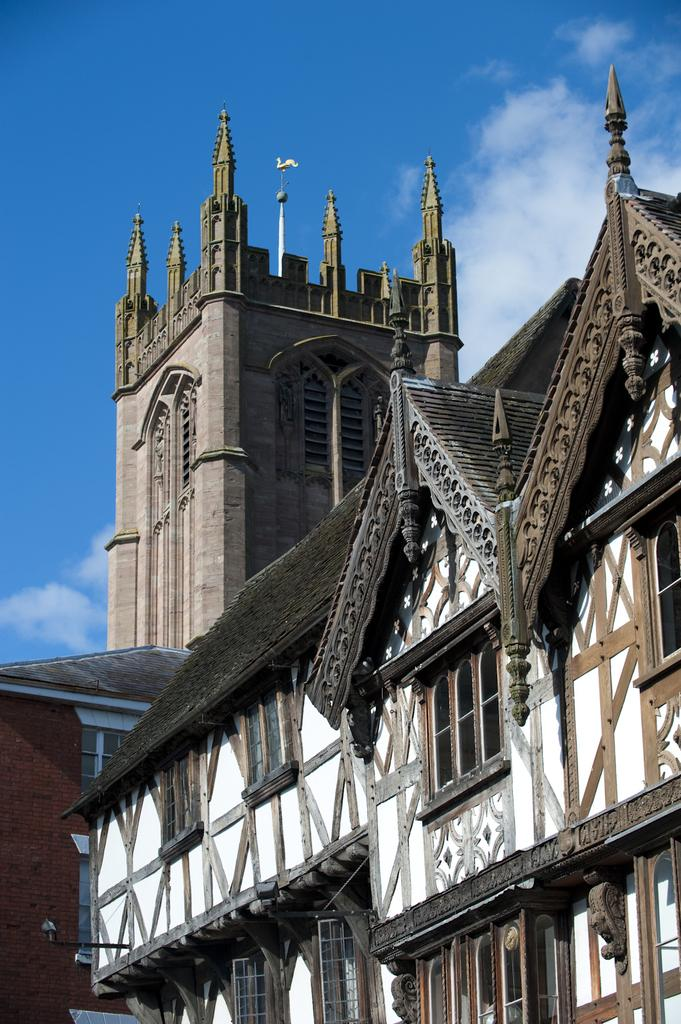What type of structures can be seen in the image? There are buildings in the image. What specific type of building is in the background? There is a castle in the background of the image. What can be seen in the sky in the image? Clouds are visible at the top of the image. What is the color of the sky in the image? The sky is blue in color. Where is the zoo located in the image? There is no zoo present in the image. Can you see any animals in the image? The image does not show any animals. 